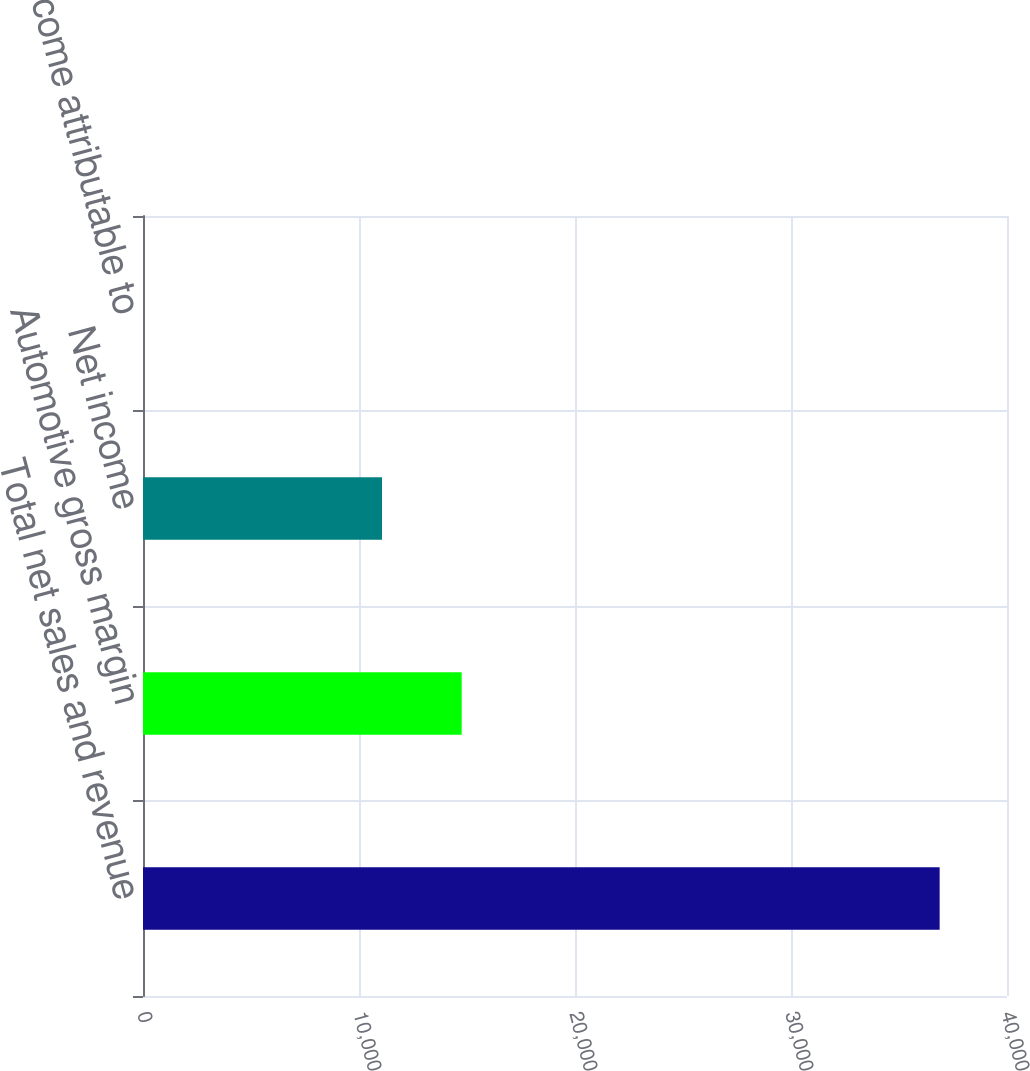Convert chart to OTSL. <chart><loc_0><loc_0><loc_500><loc_500><bar_chart><fcel>Total net sales and revenue<fcel>Automotive gross margin<fcel>Net income<fcel>Net income attributable to<nl><fcel>36882<fcel>14753<fcel>11064.8<fcel>0.31<nl></chart> 